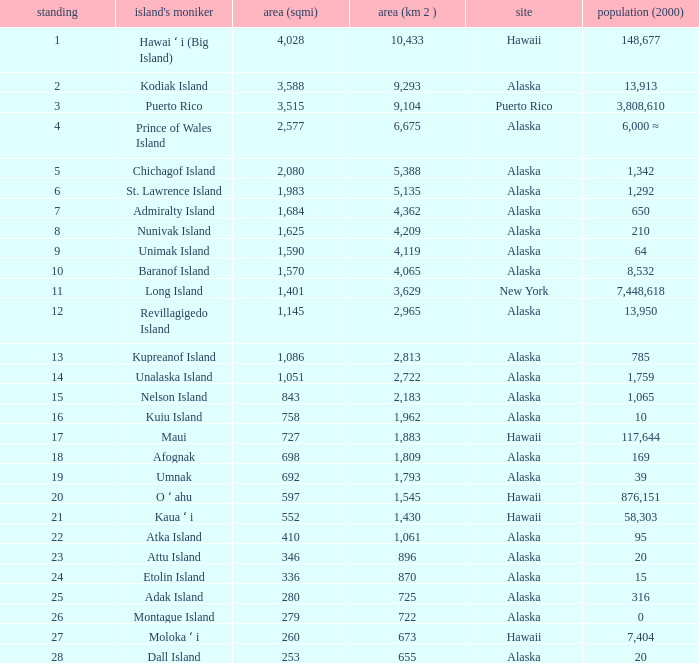What is the largest area in Alaska with a population of 39 and rank over 19? None. 